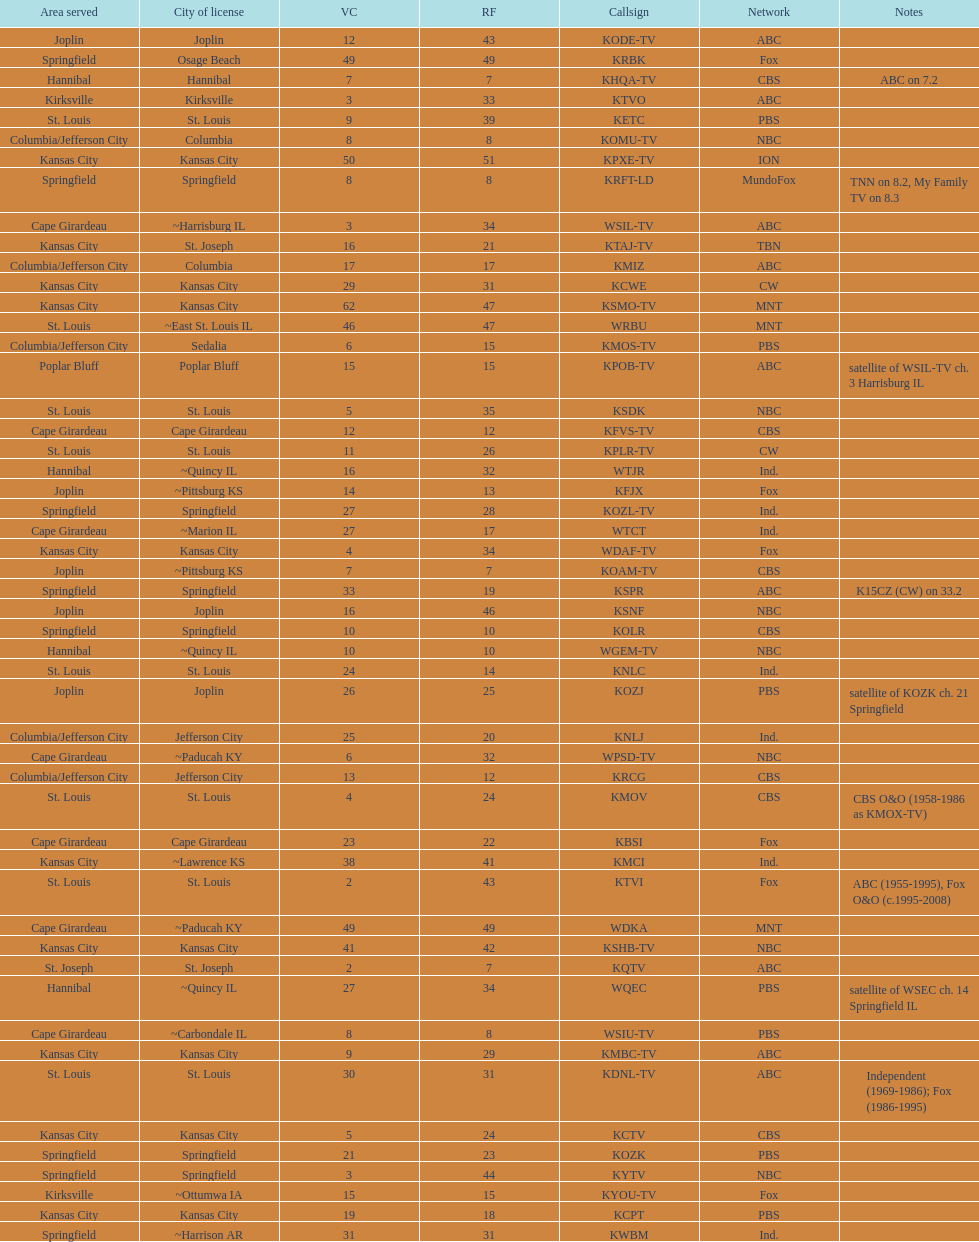What is the total number of stations under the cbs network? 7. 